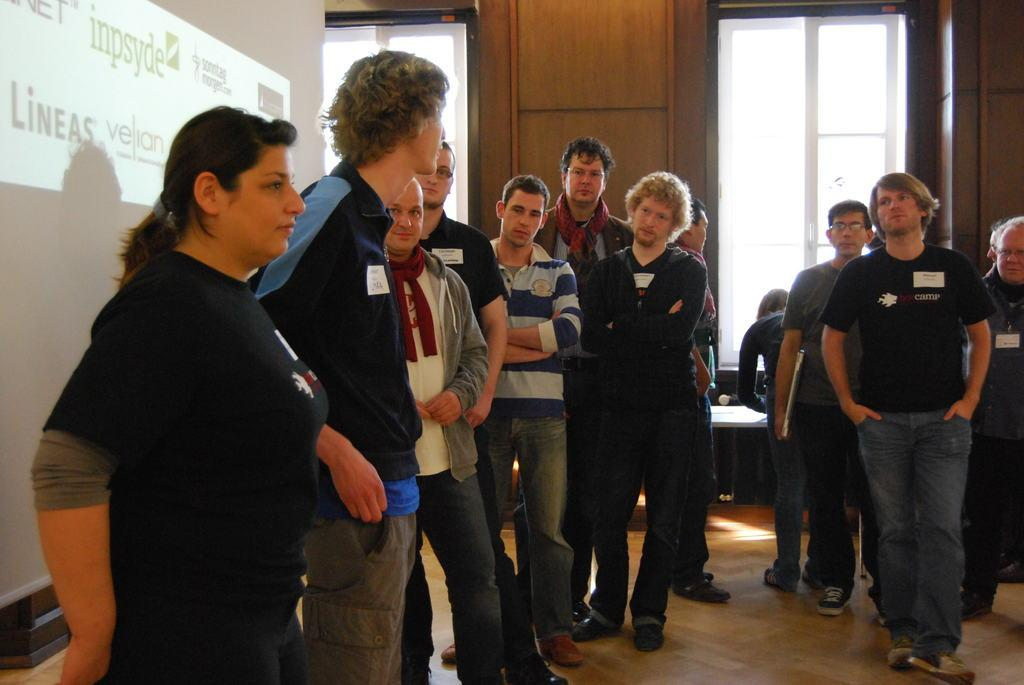What can be seen in the image involving people? There are people standing in the image. What is located on the left side of the image? There is a screen on the left side of the image. What is the surface that the people are standing on? There is a floor at the bottom of the image. What can be seen in the background of the image? There are windows and a wall in the background of the image. Can you see any fish swimming in the image? There are no fish visible in the image. Is there a trail leading to the location of the people in the image? There is no trail present in the image. 